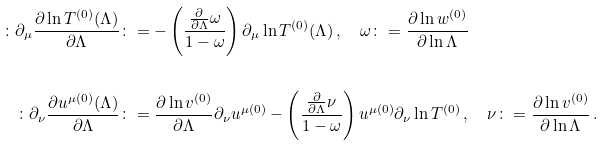<formula> <loc_0><loc_0><loc_500><loc_500>\colon \partial _ { \mu } \frac { \partial \ln T ^ { ( 0 ) } ( \Lambda ) } { \partial \Lambda } \colon & = - \left ( \frac { \frac { \partial } { \partial \Lambda } \omega } { 1 - \omega } \right ) \partial _ { \mu } \ln T ^ { ( 0 ) } ( \Lambda ) \, , \quad \omega \colon = \frac { \partial \ln w ^ { ( 0 ) } } { \partial \ln \Lambda } \\ \\ \colon \partial _ { \nu } \frac { \partial u ^ { \mu ( 0 ) } ( \Lambda ) } { \partial \Lambda } \colon & = \frac { \partial \ln v ^ { ( 0 ) } } { \partial \Lambda } \partial _ { \nu } u ^ { \mu ( 0 ) } - \left ( \frac { \frac { \partial } { \partial \Lambda } \nu } { 1 - \omega } \right ) u ^ { \mu ( 0 ) } \partial _ { \nu } \ln T ^ { ( 0 ) } \, , \quad \nu \colon = \frac { \partial \ln v ^ { ( 0 ) } } { \partial \ln \Lambda } \, .</formula> 